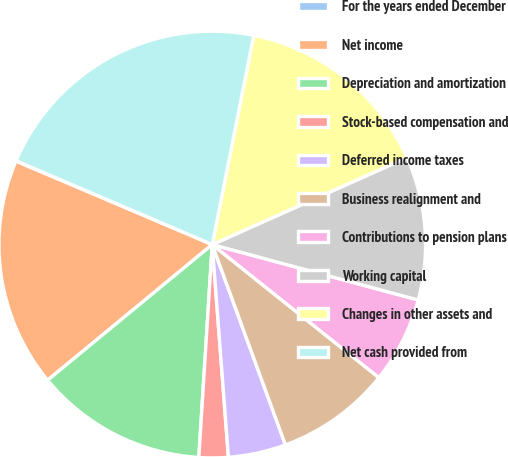Convert chart. <chart><loc_0><loc_0><loc_500><loc_500><pie_chart><fcel>For the years ended December<fcel>Net income<fcel>Depreciation and amortization<fcel>Stock-based compensation and<fcel>Deferred income taxes<fcel>Business realignment and<fcel>Contributions to pension plans<fcel>Working capital<fcel>Changes in other assets and<fcel>Net cash provided from<nl><fcel>0.04%<fcel>17.36%<fcel>13.03%<fcel>2.21%<fcel>4.37%<fcel>8.7%<fcel>6.54%<fcel>10.87%<fcel>15.2%<fcel>21.69%<nl></chart> 